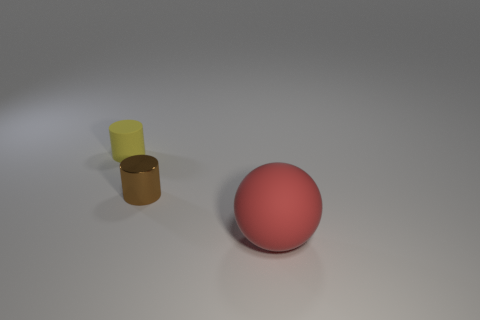The rubber object that is the same shape as the small brown metallic object is what color?
Your answer should be compact. Yellow. There is another object that is the same shape as the tiny yellow matte thing; what size is it?
Provide a short and direct response. Small. There is a tiny brown object; what number of metallic objects are behind it?
Your answer should be compact. 0. What is the color of the matte object that is to the left of the rubber thing in front of the yellow matte thing?
Your answer should be very brief. Yellow. Are there any other things that are the same shape as the large matte object?
Keep it short and to the point. No. Are there an equal number of red spheres that are in front of the red ball and tiny yellow things behind the yellow cylinder?
Ensure brevity in your answer.  Yes. How many blocks are yellow matte objects or brown metal objects?
Offer a terse response. 0. What number of other things are made of the same material as the yellow cylinder?
Keep it short and to the point. 1. There is a matte object on the left side of the tiny brown metal cylinder; what is its shape?
Keep it short and to the point. Cylinder. What material is the small cylinder that is in front of the matte object that is behind the large ball made of?
Offer a very short reply. Metal. 